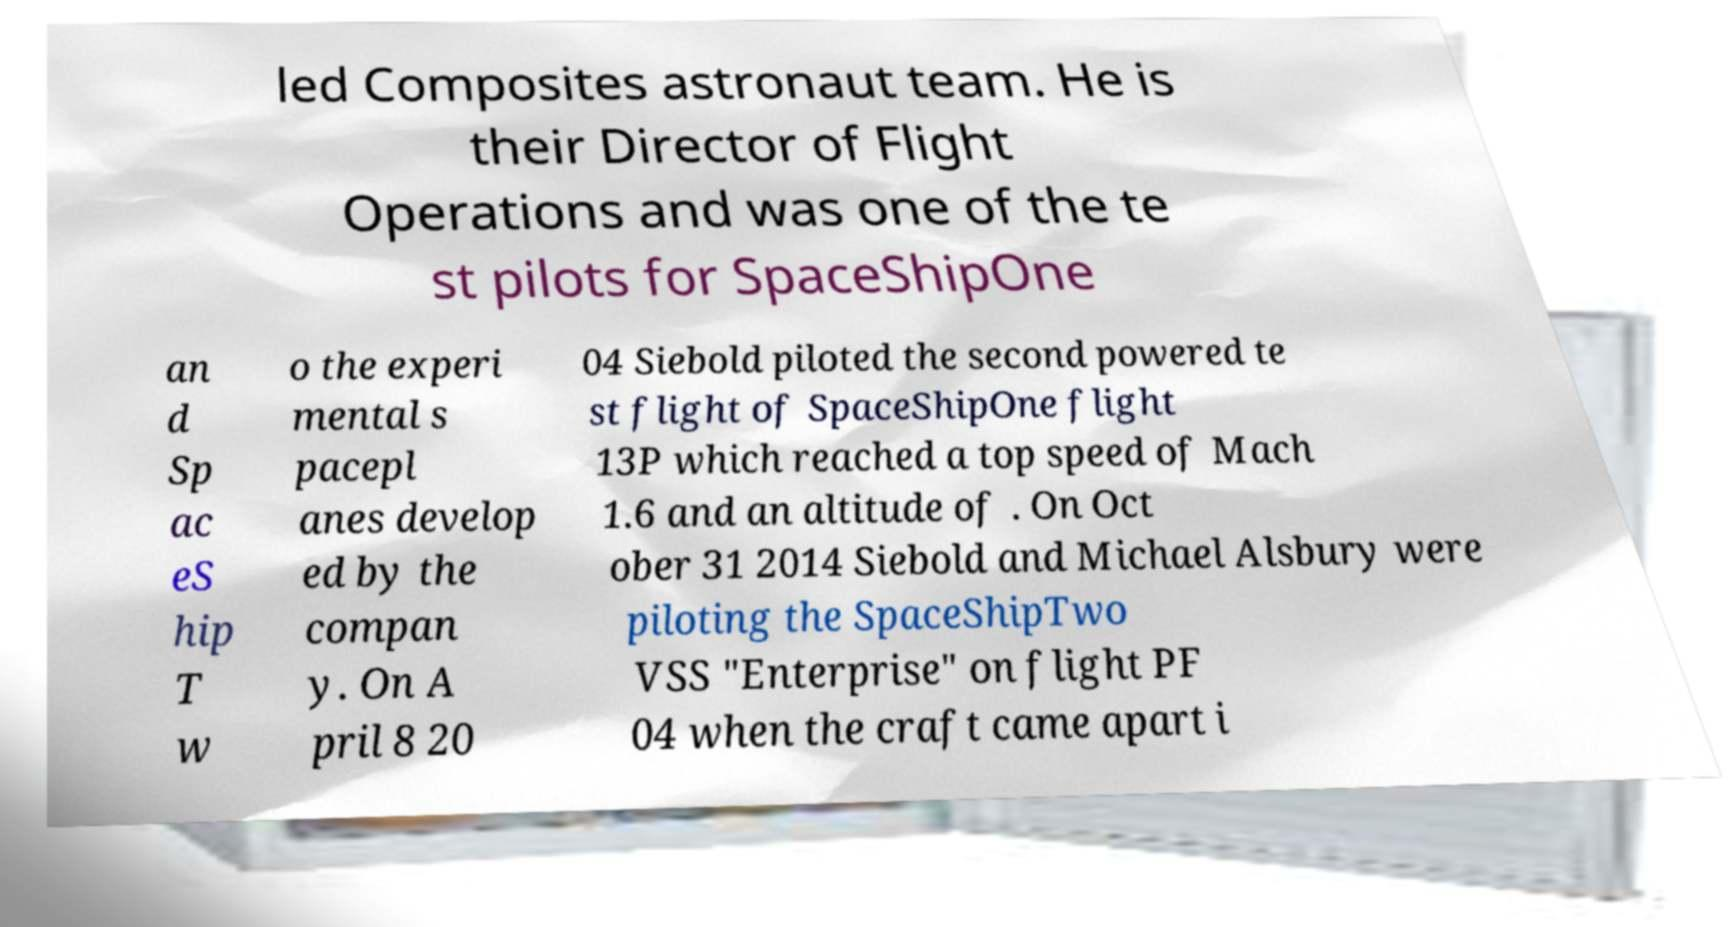I need the written content from this picture converted into text. Can you do that? led Composites astronaut team. He is their Director of Flight Operations and was one of the te st pilots for SpaceShipOne an d Sp ac eS hip T w o the experi mental s pacepl anes develop ed by the compan y. On A pril 8 20 04 Siebold piloted the second powered te st flight of SpaceShipOne flight 13P which reached a top speed of Mach 1.6 and an altitude of . On Oct ober 31 2014 Siebold and Michael Alsbury were piloting the SpaceShipTwo VSS "Enterprise" on flight PF 04 when the craft came apart i 